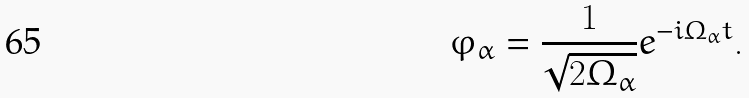<formula> <loc_0><loc_0><loc_500><loc_500>\varphi _ { \alpha } = \frac { 1 } { \sqrt { 2 \Omega _ { \alpha } } } e ^ { - i \Omega _ { \alpha } t } .</formula> 